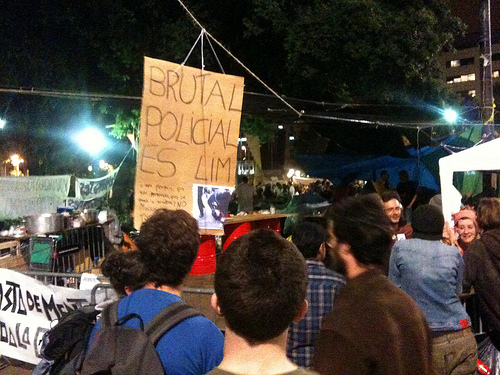<image>
Is the man to the left of the man? Yes. From this viewpoint, the man is positioned to the left side relative to the man. 